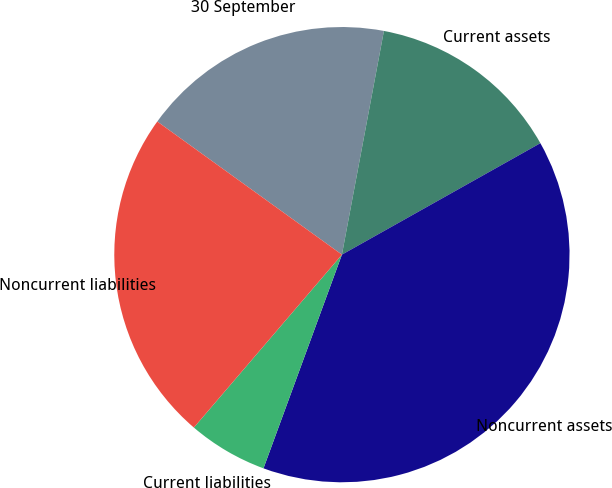<chart> <loc_0><loc_0><loc_500><loc_500><pie_chart><fcel>30 September<fcel>Current assets<fcel>Noncurrent assets<fcel>Current liabilities<fcel>Noncurrent liabilities<nl><fcel>18.01%<fcel>13.9%<fcel>38.74%<fcel>5.67%<fcel>23.67%<nl></chart> 